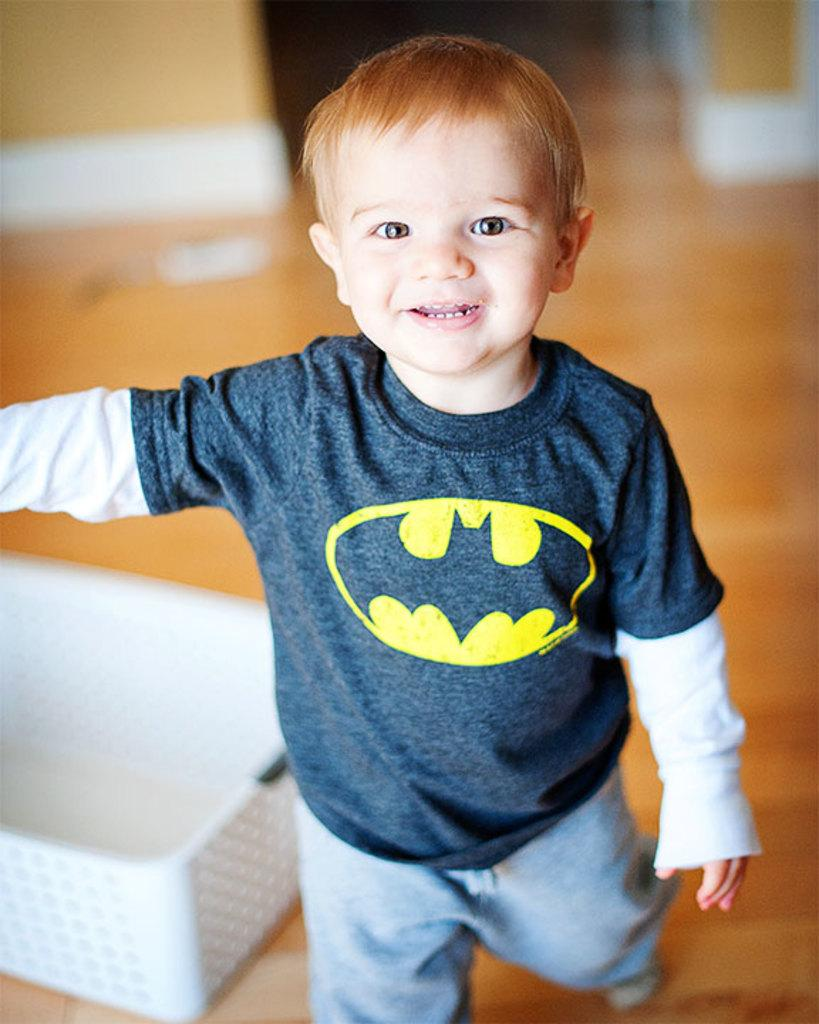Who is the main subject in the picture? There is a boy in the picture. What is the boy doing in the picture? The boy is standing on the floor. What is the boy wearing in the picture? The boy is wearing a t-shirt and pants. What other object can be seen in the picture? There is a white-colored basket in the picture. What type of patch is sewn onto the boy's t-shirt in the image? There is no patch visible on the boy's t-shirt in the image. Can you tell me how many keys are hanging from the boy's belt in the image? There are no keys present in the image. 